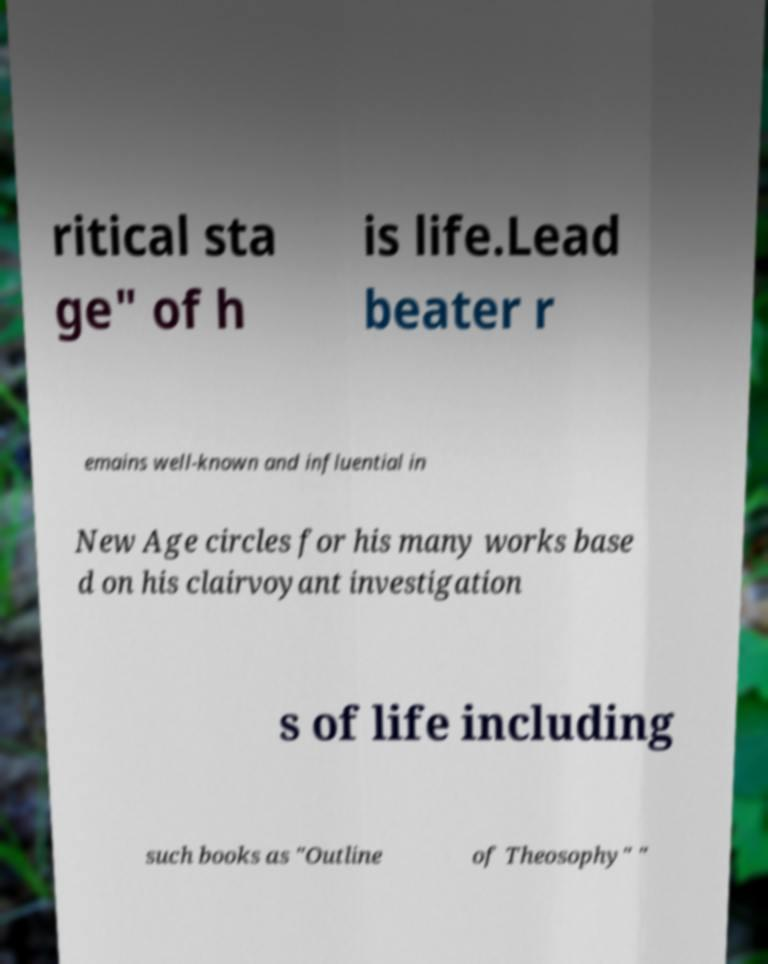Please read and relay the text visible in this image. What does it say? ritical sta ge" of h is life.Lead beater r emains well-known and influential in New Age circles for his many works base d on his clairvoyant investigation s of life including such books as "Outline of Theosophy" " 